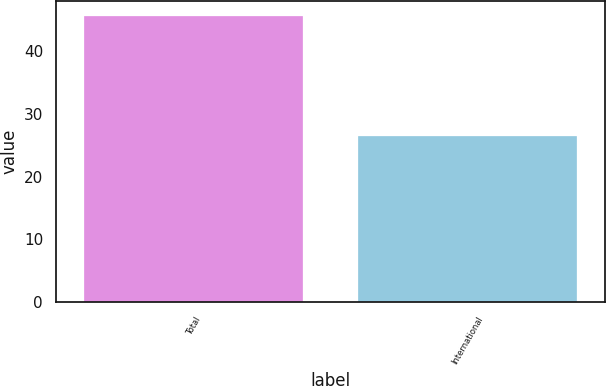<chart> <loc_0><loc_0><loc_500><loc_500><bar_chart><fcel>Total<fcel>International<nl><fcel>45.7<fcel>26.5<nl></chart> 